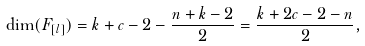<formula> <loc_0><loc_0><loc_500><loc_500>\dim ( F _ { [ l ] } ) = k + c - 2 - \frac { n + k - 2 } { 2 } = \frac { k + 2 c - 2 - n } { 2 } ,</formula> 